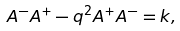<formula> <loc_0><loc_0><loc_500><loc_500>A ^ { - } A ^ { + } - q ^ { 2 } A ^ { + } A ^ { - } = k ,</formula> 